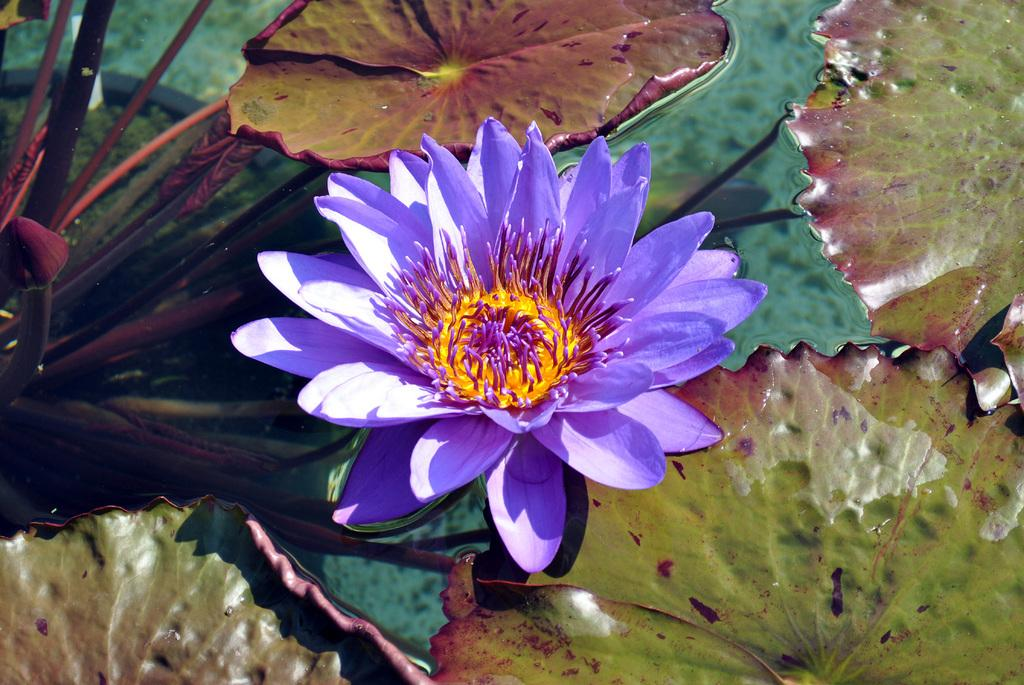What is the main subject of the image? There is a flower in the image. What color is the flower? The flower is purple. Are there any other plant elements visible in the image? Yes, there are leaves in the image. Where are the flower and leaves located? The flower and leaves are in the water. What type of jeans is the flower wearing in the image? There are no jeans present in the image, as flowers do not wear clothing. 